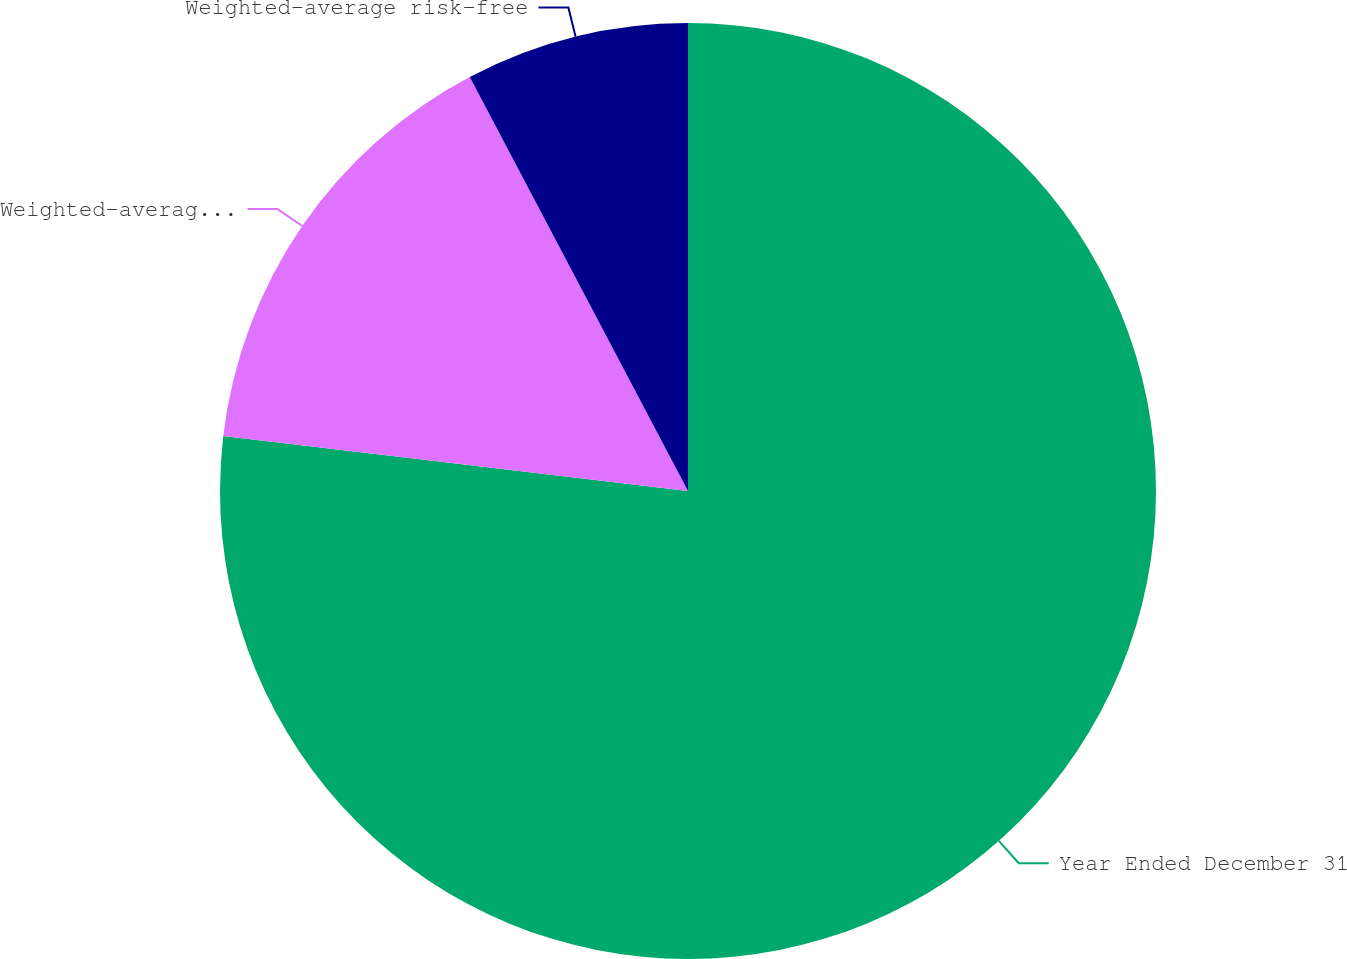Convert chart to OTSL. <chart><loc_0><loc_0><loc_500><loc_500><pie_chart><fcel>Year Ended December 31<fcel>Weighted-average expected<fcel>Weighted-average risk-free<nl><fcel>76.87%<fcel>15.4%<fcel>7.72%<nl></chart> 